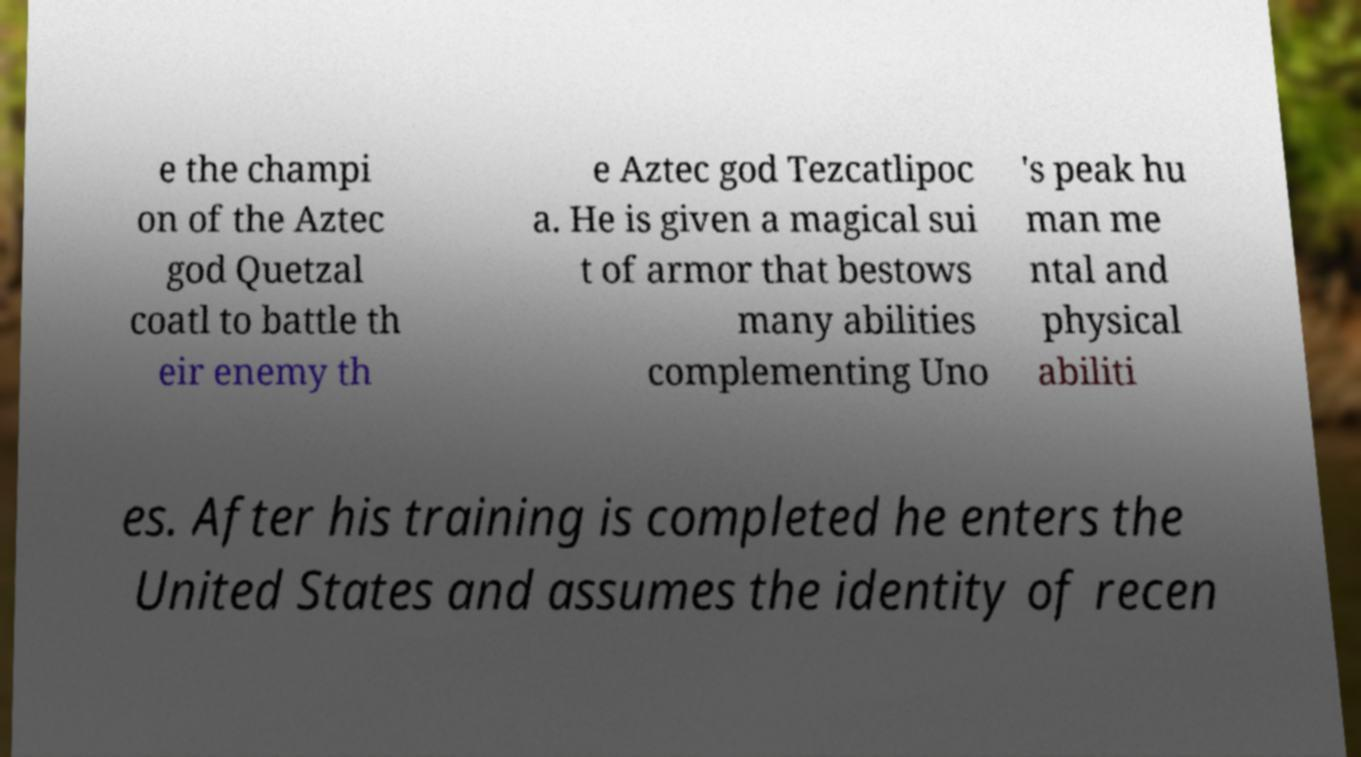Please identify and transcribe the text found in this image. e the champi on of the Aztec god Quetzal coatl to battle th eir enemy th e Aztec god Tezcatlipoc a. He is given a magical sui t of armor that bestows many abilities complementing Uno 's peak hu man me ntal and physical abiliti es. After his training is completed he enters the United States and assumes the identity of recen 